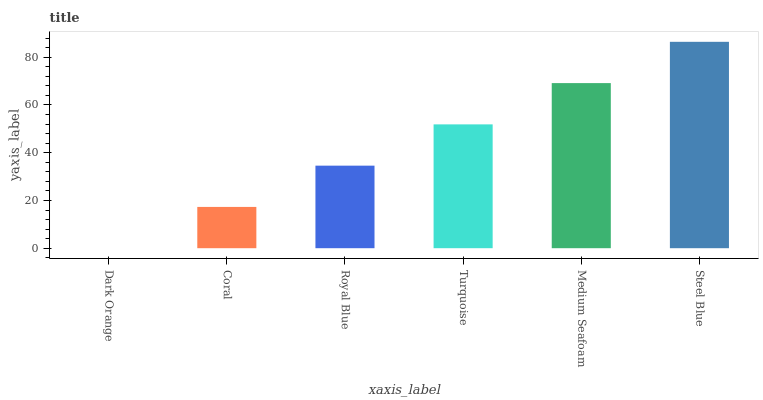Is Dark Orange the minimum?
Answer yes or no. Yes. Is Steel Blue the maximum?
Answer yes or no. Yes. Is Coral the minimum?
Answer yes or no. No. Is Coral the maximum?
Answer yes or no. No. Is Coral greater than Dark Orange?
Answer yes or no. Yes. Is Dark Orange less than Coral?
Answer yes or no. Yes. Is Dark Orange greater than Coral?
Answer yes or no. No. Is Coral less than Dark Orange?
Answer yes or no. No. Is Turquoise the high median?
Answer yes or no. Yes. Is Royal Blue the low median?
Answer yes or no. Yes. Is Steel Blue the high median?
Answer yes or no. No. Is Dark Orange the low median?
Answer yes or no. No. 